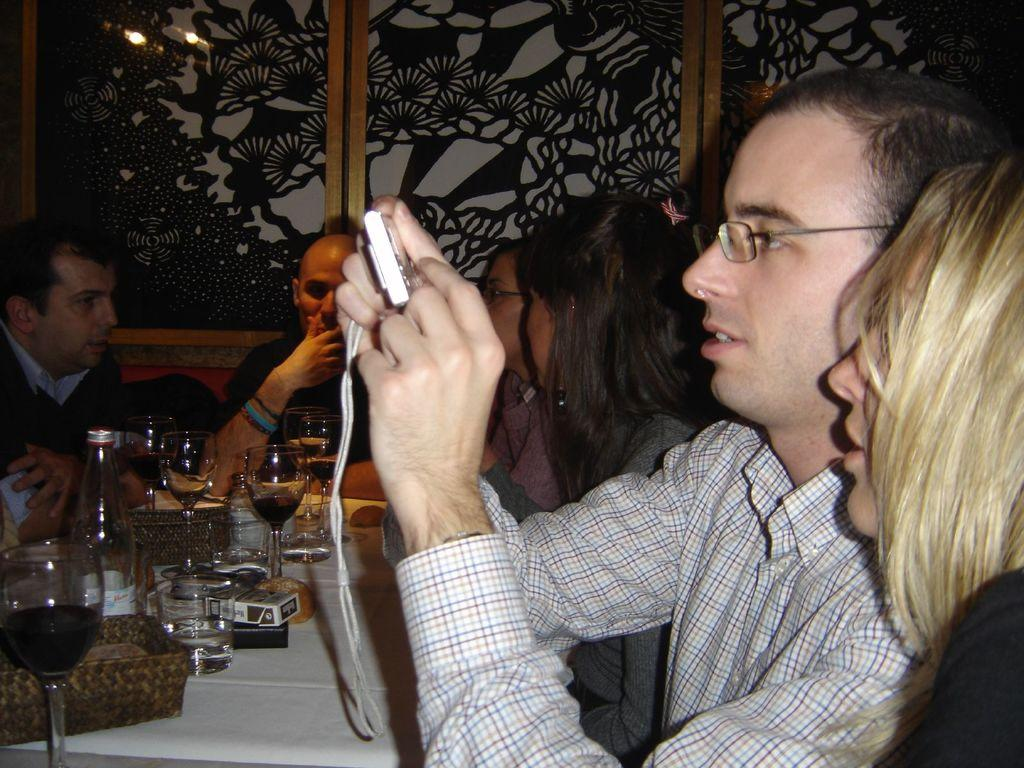How many people are in the image? There is a group of people in the image. What are the people doing in the image? The people are sitting on chairs. What is on the table in the image? There is a glass, a bottle, and a tray on the table. What can be seen in the background of the image? There is a curtain visible in the background of the image. What type of bone can be seen in the image? There is no bone present in the image. Is there a camera visible in the image? There is no camera present in the image. 